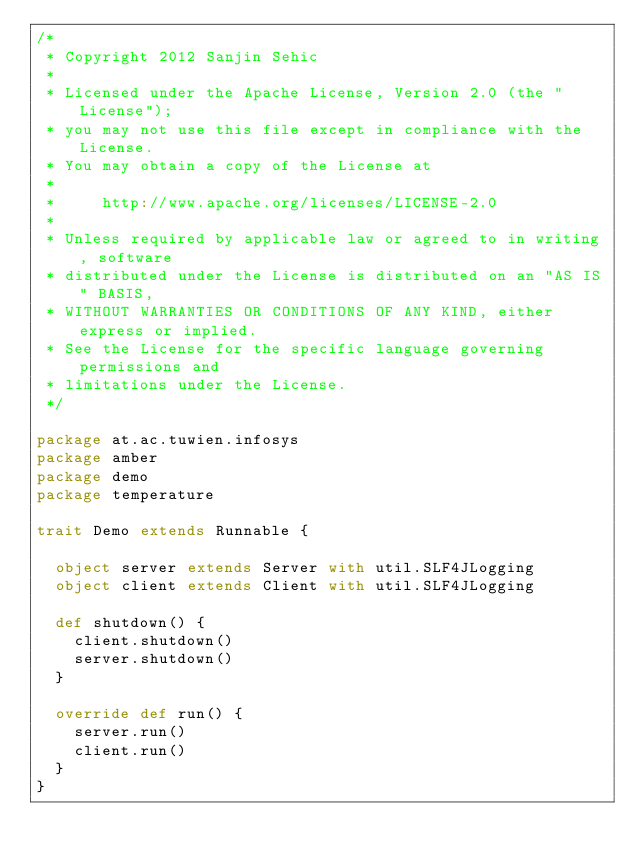Convert code to text. <code><loc_0><loc_0><loc_500><loc_500><_Scala_>/*
 * Copyright 2012 Sanjin Sehic
 *
 * Licensed under the Apache License, Version 2.0 (the "License");
 * you may not use this file except in compliance with the License.
 * You may obtain a copy of the License at
 *
 *     http://www.apache.org/licenses/LICENSE-2.0
 *
 * Unless required by applicable law or agreed to in writing, software
 * distributed under the License is distributed on an "AS IS" BASIS,
 * WITHOUT WARRANTIES OR CONDITIONS OF ANY KIND, either express or implied.
 * See the License for the specific language governing permissions and
 * limitations under the License.
 */

package at.ac.tuwien.infosys
package amber
package demo
package temperature

trait Demo extends Runnable {

  object server extends Server with util.SLF4JLogging
  object client extends Client with util.SLF4JLogging

  def shutdown() {
    client.shutdown()
    server.shutdown()
  }

  override def run() {
    server.run()
    client.run()
  }
}
</code> 